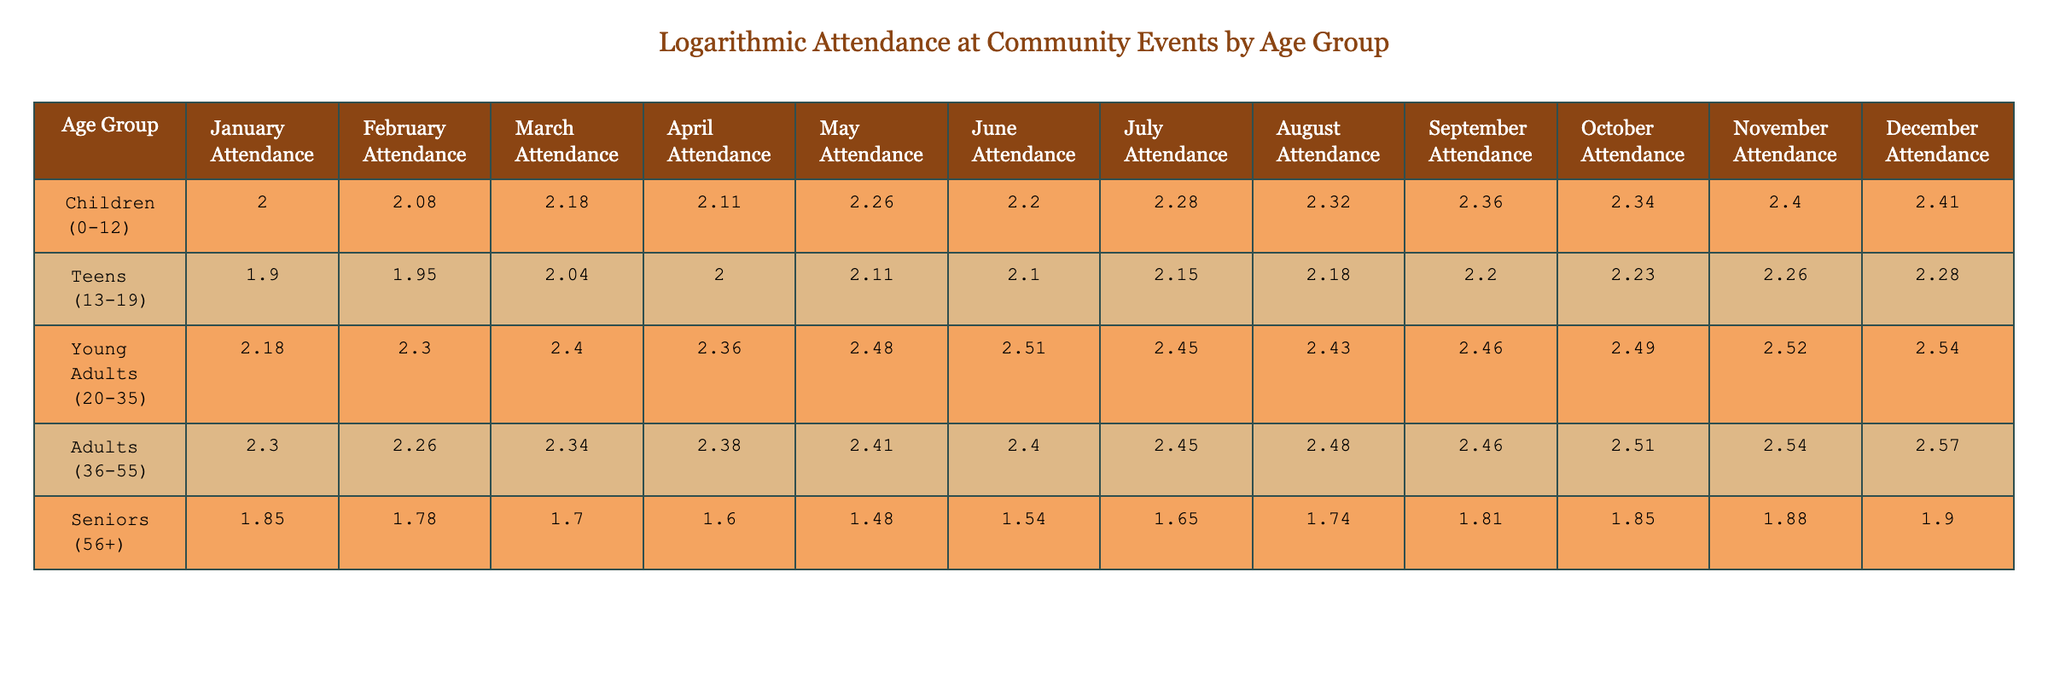What is the logarithmic attendance of seniors in December? The table shows the logarithmic attendance value for seniors in December, which is specifically listed under the "December Attendance" column for the "Seniors (56+)" age group. The value is 1.90.
Answer: 1.90 What was the highest attendance for the Young Adults age group? The highest attendance for Young Adults can be found by looking through the "January Attendance" to "December Attendance" columns. The maximum value is 350, which appears in December.
Answer: 350 How does the average attendance for Children compare to that of Teens in August? For Children, the attendance in August is 2.32, and for Teens, it is 2.18 (both calculated from their attendance values). The average attendance for Children in August is greater than that of Teens.
Answer: Children have higher attendance Is it true that Seniors had their lowest attendance in April? To answer this, we check the attendance for Seniors across all months. The lowest attendance occurs in April with a value of 1.60, indicating that this is indeed true.
Answer: Yes What is the total logarithmic attendance for adults from January to April? By identifying and adding the logarithmic attendance values for Adults from January to April (2.30, 2.25, 2.34, 2.38), we calculate the total: 2.30 + 2.25 + 2.34 + 2.38 = 9.27.
Answer: 9.27 Does the attendance of Young Adults generally increase toward the end of the year? To determine this, we compare the attendance values from the beginning to the end of the year. Starting from January (2.18) and ending in December (2.44), the values do indeed show a consistent increase over the months, indicating a general upward trend.
Answer: Yes What is the difference in attendance between Adults and Seniors in October? The attendance values for Adults and Seniors in October are 2.53 and 1.84 respectively. The difference is calculated by subtracting Seniors' attendance from Adults', resulting in 2.53 - 1.84 = 0.69.
Answer: 0.69 Which age group had a consistent attendance above 100 throughout the year? By examining the attendance values for each age group month by month, we can see that the age groups Children, Teens, Young Adults, and Adults maintained values above 100 in every month, while Seniors did not.
Answer: Children, Teens, Young Adults, Adults What was the attendance trend for Seniors throughout the year? By analyzing the values for Seniors over the months, they show a decreasing trend from January (2.84) to April (1.60), followed by a slight increase until December (1.90). Overall, the trend reflects a decline in the first half of the year and a slight recovery later.
Answer: Decreasing with a slight recovery in the second half 